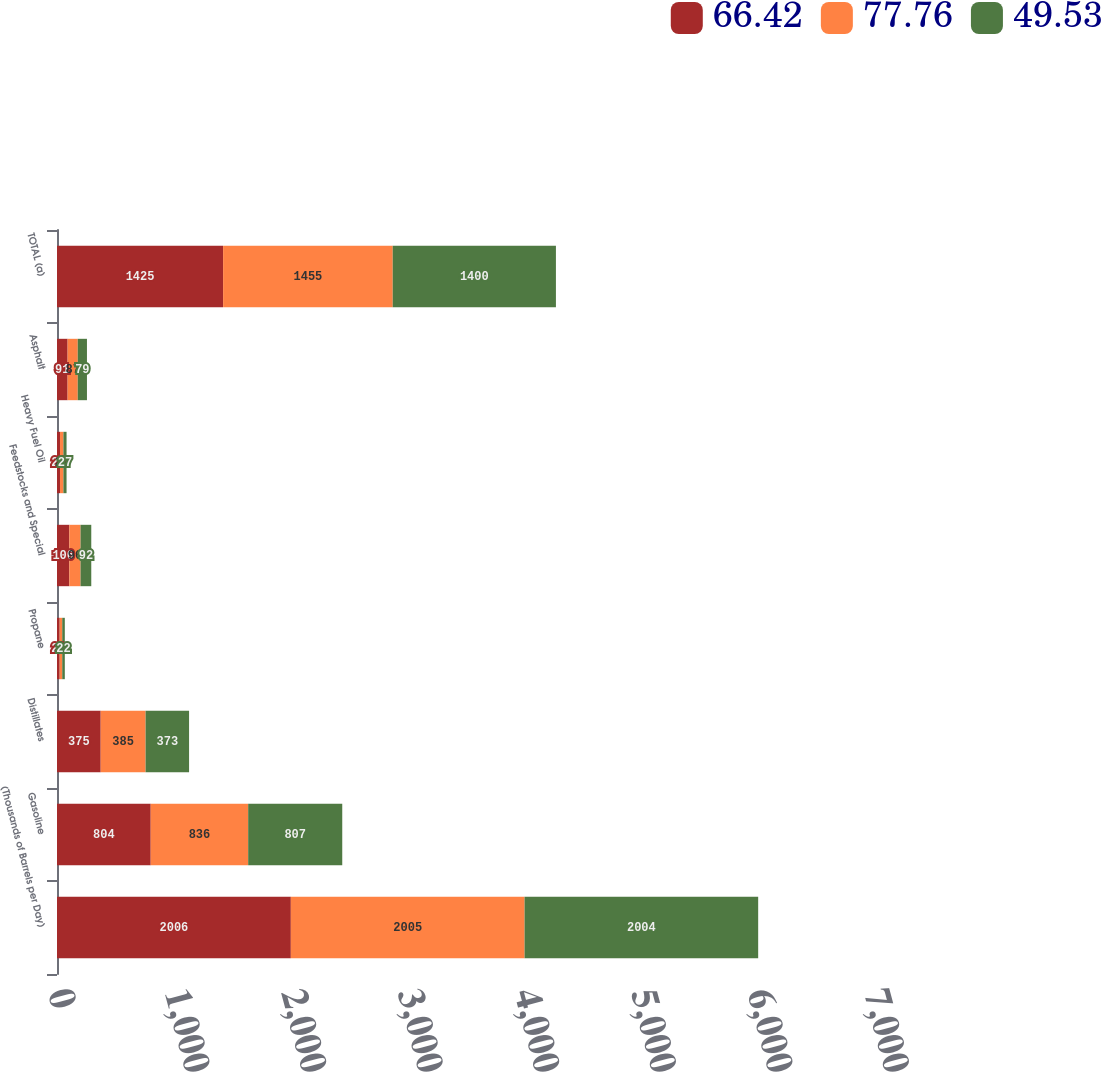<chart> <loc_0><loc_0><loc_500><loc_500><stacked_bar_chart><ecel><fcel>(Thousands of Barrels per Day)<fcel>Gasoline<fcel>Distillates<fcel>Propane<fcel>Feedstocks and Special<fcel>Heavy Fuel Oil<fcel>Asphalt<fcel>TOTAL (a)<nl><fcel>66.42<fcel>2006<fcel>804<fcel>375<fcel>23<fcel>106<fcel>26<fcel>91<fcel>1425<nl><fcel>77.76<fcel>2005<fcel>836<fcel>385<fcel>22<fcel>96<fcel>29<fcel>87<fcel>1455<nl><fcel>49.53<fcel>2004<fcel>807<fcel>373<fcel>22<fcel>92<fcel>27<fcel>79<fcel>1400<nl></chart> 